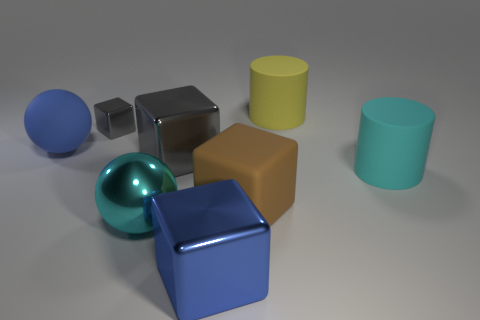The other big cylinder that is the same material as the yellow cylinder is what color?
Give a very brief answer. Cyan. Do the yellow matte object and the large cyan metallic thing have the same shape?
Offer a very short reply. No. What number of matte things are behind the large blue sphere and in front of the tiny block?
Ensure brevity in your answer.  0. How many metallic things are yellow things or gray objects?
Give a very brief answer. 2. What size is the block that is behind the big gray shiny thing in front of the blue rubber ball?
Provide a succinct answer. Small. There is a large cylinder that is the same color as the large shiny ball; what is its material?
Offer a very short reply. Rubber. Are there any matte things that are to the right of the cylinder on the left side of the rubber cylinder that is in front of the large blue matte object?
Provide a short and direct response. Yes. Is the material of the large blue object that is left of the tiny object the same as the big cylinder in front of the big gray metallic thing?
Ensure brevity in your answer.  Yes. How many things are either tiny blue cylinders or large cyan objects that are left of the large brown object?
Make the answer very short. 1. What number of other tiny metallic things have the same shape as the cyan shiny object?
Offer a very short reply. 0. 